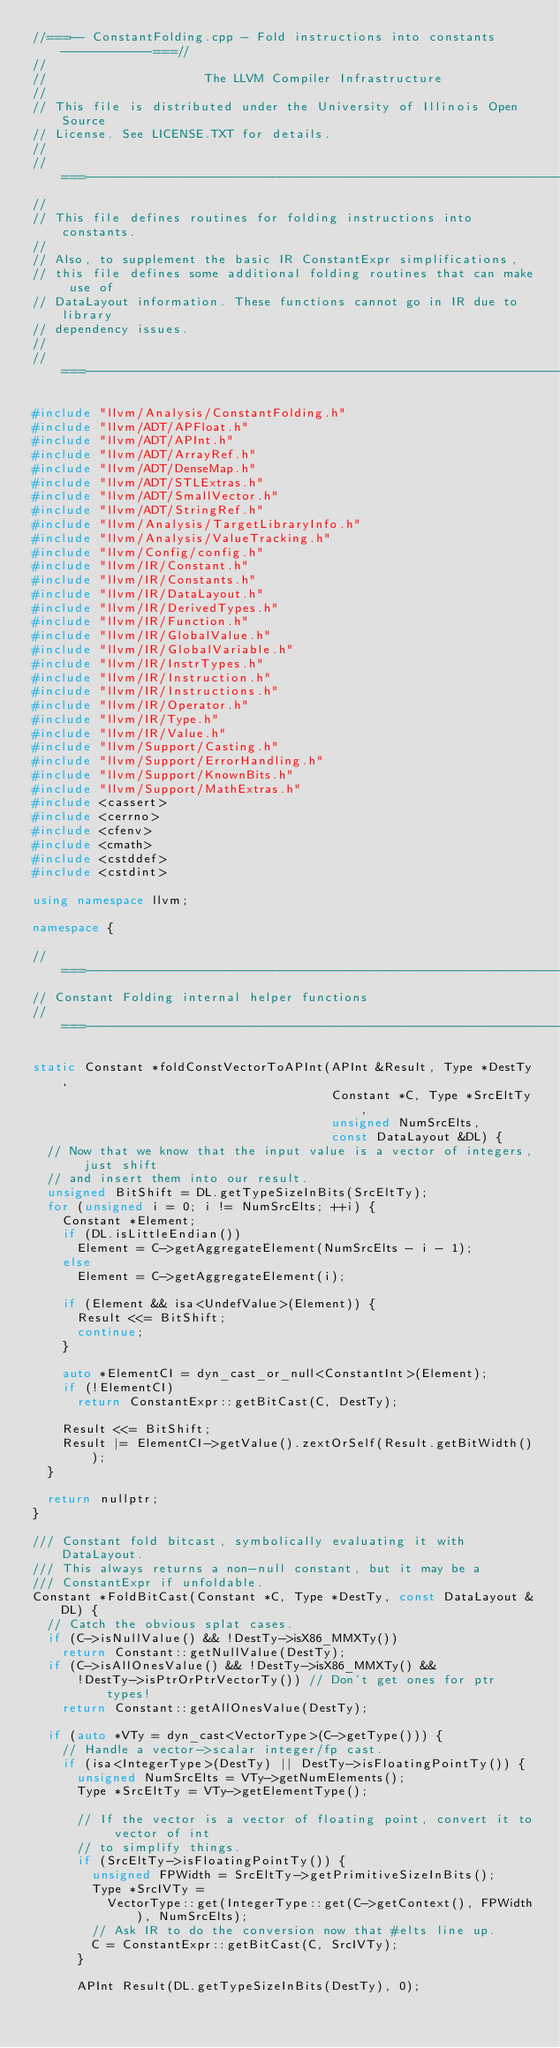Convert code to text. <code><loc_0><loc_0><loc_500><loc_500><_C++_>//===-- ConstantFolding.cpp - Fold instructions into constants ------------===//
//
//                     The LLVM Compiler Infrastructure
//
// This file is distributed under the University of Illinois Open Source
// License. See LICENSE.TXT for details.
//
//===----------------------------------------------------------------------===//
//
// This file defines routines for folding instructions into constants.
//
// Also, to supplement the basic IR ConstantExpr simplifications,
// this file defines some additional folding routines that can make use of
// DataLayout information. These functions cannot go in IR due to library
// dependency issues.
//
//===----------------------------------------------------------------------===//

#include "llvm/Analysis/ConstantFolding.h"
#include "llvm/ADT/APFloat.h"
#include "llvm/ADT/APInt.h"
#include "llvm/ADT/ArrayRef.h"
#include "llvm/ADT/DenseMap.h"
#include "llvm/ADT/STLExtras.h"
#include "llvm/ADT/SmallVector.h"
#include "llvm/ADT/StringRef.h"
#include "llvm/Analysis/TargetLibraryInfo.h"
#include "llvm/Analysis/ValueTracking.h"
#include "llvm/Config/config.h"
#include "llvm/IR/Constant.h"
#include "llvm/IR/Constants.h"
#include "llvm/IR/DataLayout.h"
#include "llvm/IR/DerivedTypes.h"
#include "llvm/IR/Function.h"
#include "llvm/IR/GlobalValue.h"
#include "llvm/IR/GlobalVariable.h"
#include "llvm/IR/InstrTypes.h"
#include "llvm/IR/Instruction.h"
#include "llvm/IR/Instructions.h"
#include "llvm/IR/Operator.h"
#include "llvm/IR/Type.h"
#include "llvm/IR/Value.h"
#include "llvm/Support/Casting.h"
#include "llvm/Support/ErrorHandling.h"
#include "llvm/Support/KnownBits.h"
#include "llvm/Support/MathExtras.h"
#include <cassert>
#include <cerrno>
#include <cfenv>
#include <cmath>
#include <cstddef>
#include <cstdint>

using namespace llvm;

namespace {

//===----------------------------------------------------------------------===//
// Constant Folding internal helper functions
//===----------------------------------------------------------------------===//

static Constant *foldConstVectorToAPInt(APInt &Result, Type *DestTy,
                                        Constant *C, Type *SrcEltTy,
                                        unsigned NumSrcElts,
                                        const DataLayout &DL) {
  // Now that we know that the input value is a vector of integers, just shift
  // and insert them into our result.
  unsigned BitShift = DL.getTypeSizeInBits(SrcEltTy);
  for (unsigned i = 0; i != NumSrcElts; ++i) {
    Constant *Element;
    if (DL.isLittleEndian())
      Element = C->getAggregateElement(NumSrcElts - i - 1);
    else
      Element = C->getAggregateElement(i);

    if (Element && isa<UndefValue>(Element)) {
      Result <<= BitShift;
      continue;
    }

    auto *ElementCI = dyn_cast_or_null<ConstantInt>(Element);
    if (!ElementCI)
      return ConstantExpr::getBitCast(C, DestTy);

    Result <<= BitShift;
    Result |= ElementCI->getValue().zextOrSelf(Result.getBitWidth());
  }

  return nullptr;
}

/// Constant fold bitcast, symbolically evaluating it with DataLayout.
/// This always returns a non-null constant, but it may be a
/// ConstantExpr if unfoldable.
Constant *FoldBitCast(Constant *C, Type *DestTy, const DataLayout &DL) {
  // Catch the obvious splat cases.
  if (C->isNullValue() && !DestTy->isX86_MMXTy())
    return Constant::getNullValue(DestTy);
  if (C->isAllOnesValue() && !DestTy->isX86_MMXTy() &&
      !DestTy->isPtrOrPtrVectorTy()) // Don't get ones for ptr types!
    return Constant::getAllOnesValue(DestTy);

  if (auto *VTy = dyn_cast<VectorType>(C->getType())) {
    // Handle a vector->scalar integer/fp cast.
    if (isa<IntegerType>(DestTy) || DestTy->isFloatingPointTy()) {
      unsigned NumSrcElts = VTy->getNumElements();
      Type *SrcEltTy = VTy->getElementType();

      // If the vector is a vector of floating point, convert it to vector of int
      // to simplify things.
      if (SrcEltTy->isFloatingPointTy()) {
        unsigned FPWidth = SrcEltTy->getPrimitiveSizeInBits();
        Type *SrcIVTy =
          VectorType::get(IntegerType::get(C->getContext(), FPWidth), NumSrcElts);
        // Ask IR to do the conversion now that #elts line up.
        C = ConstantExpr::getBitCast(C, SrcIVTy);
      }

      APInt Result(DL.getTypeSizeInBits(DestTy), 0);</code> 